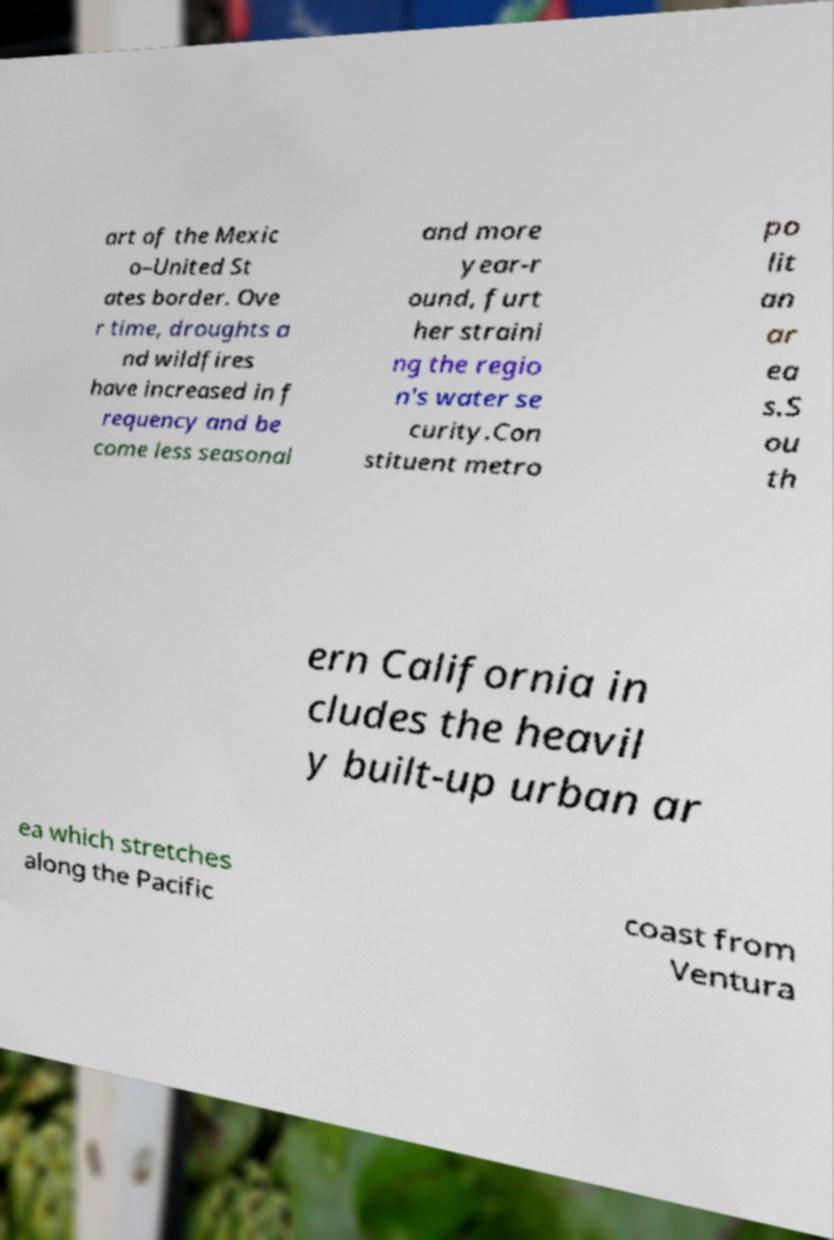Can you accurately transcribe the text from the provided image for me? art of the Mexic o–United St ates border. Ove r time, droughts a nd wildfires have increased in f requency and be come less seasonal and more year-r ound, furt her straini ng the regio n's water se curity.Con stituent metro po lit an ar ea s.S ou th ern California in cludes the heavil y built-up urban ar ea which stretches along the Pacific coast from Ventura 